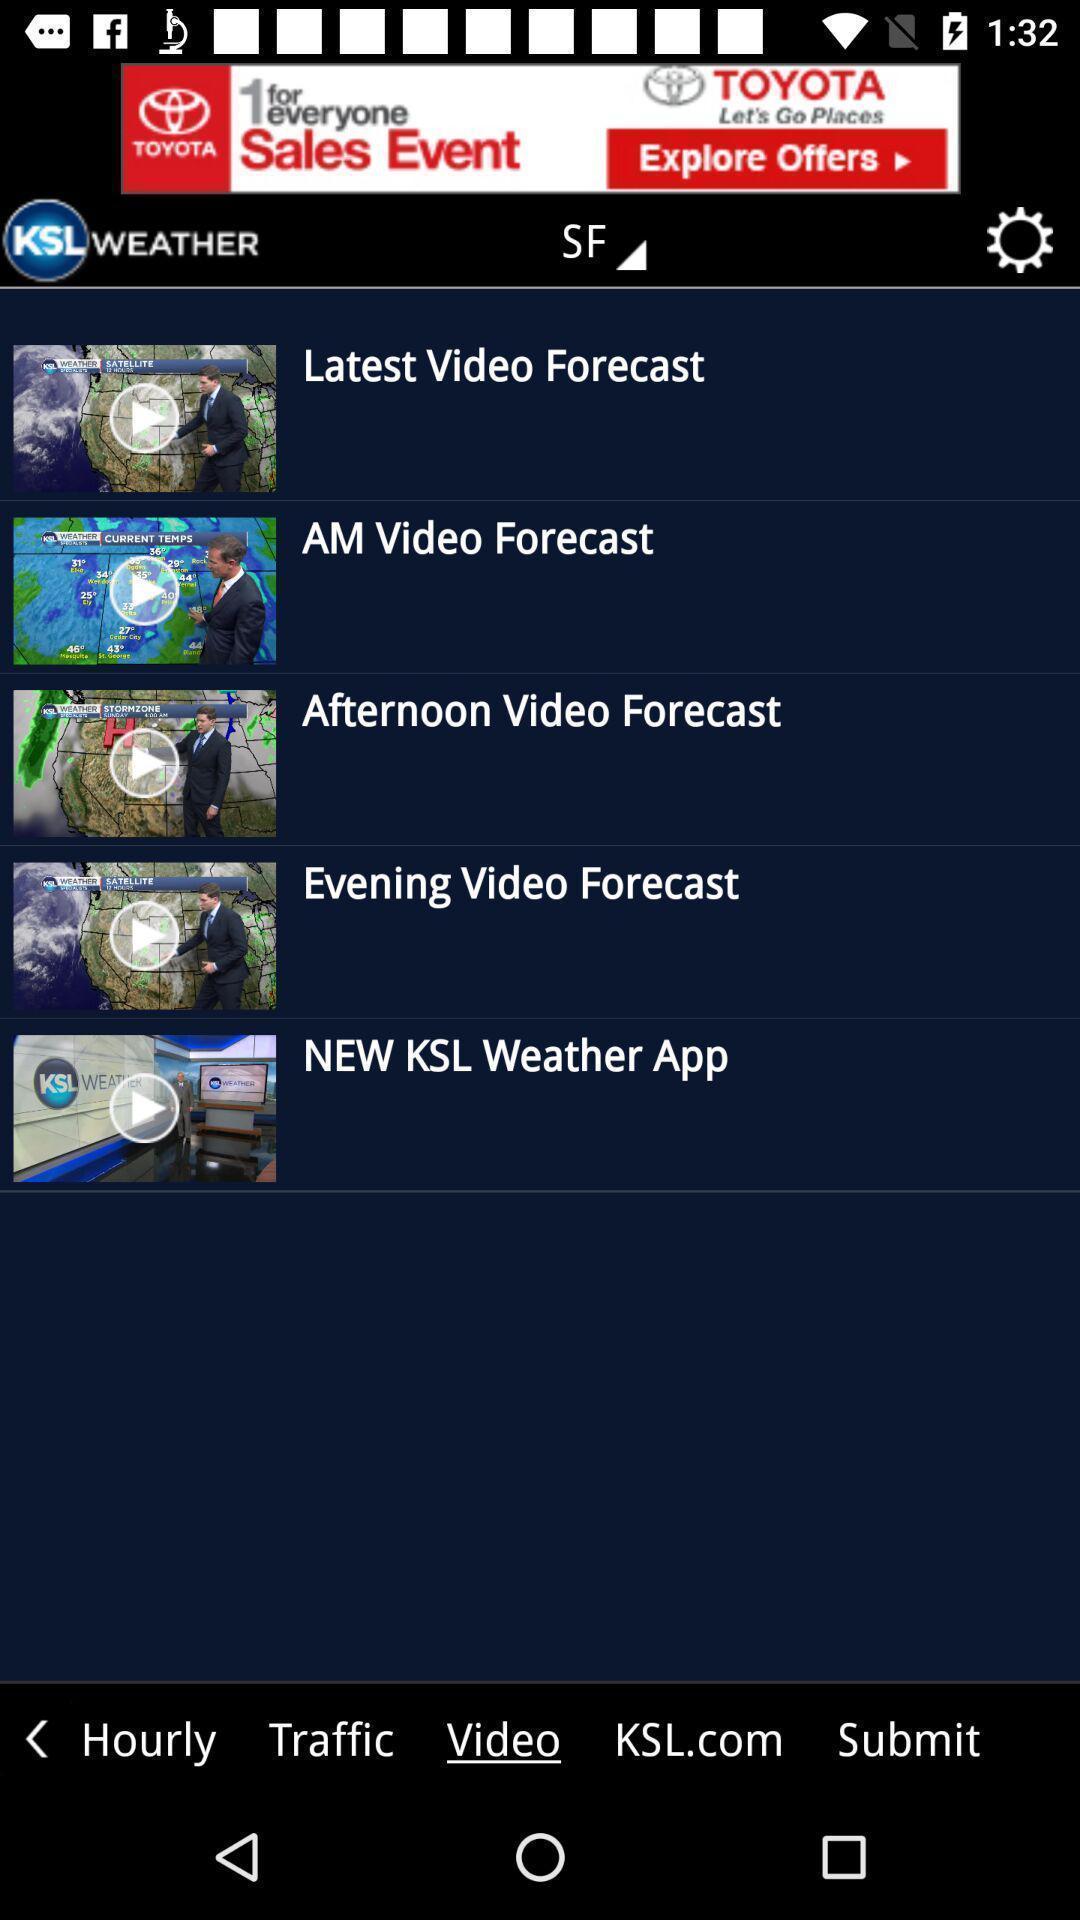Describe the key features of this screenshot. Screen displaying videos of weather forecast. 